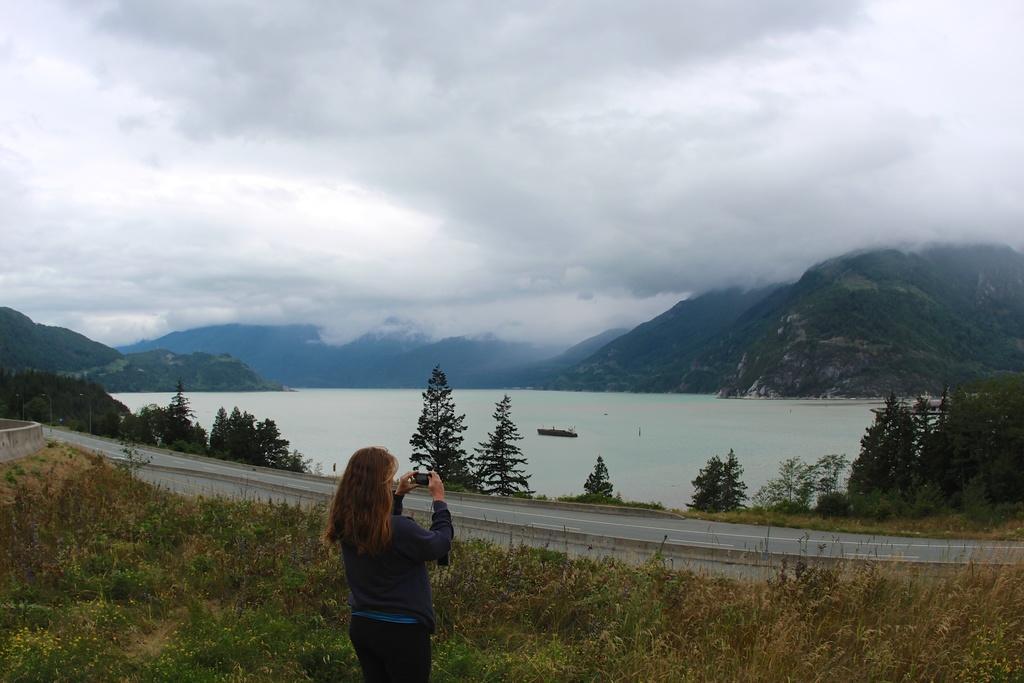Please provide a concise description of this image. In this picture we can see a woman holding a mobile with her hands and standing, trees, road, mountains and a boat on water and in the background we can see the sky with clouds. 